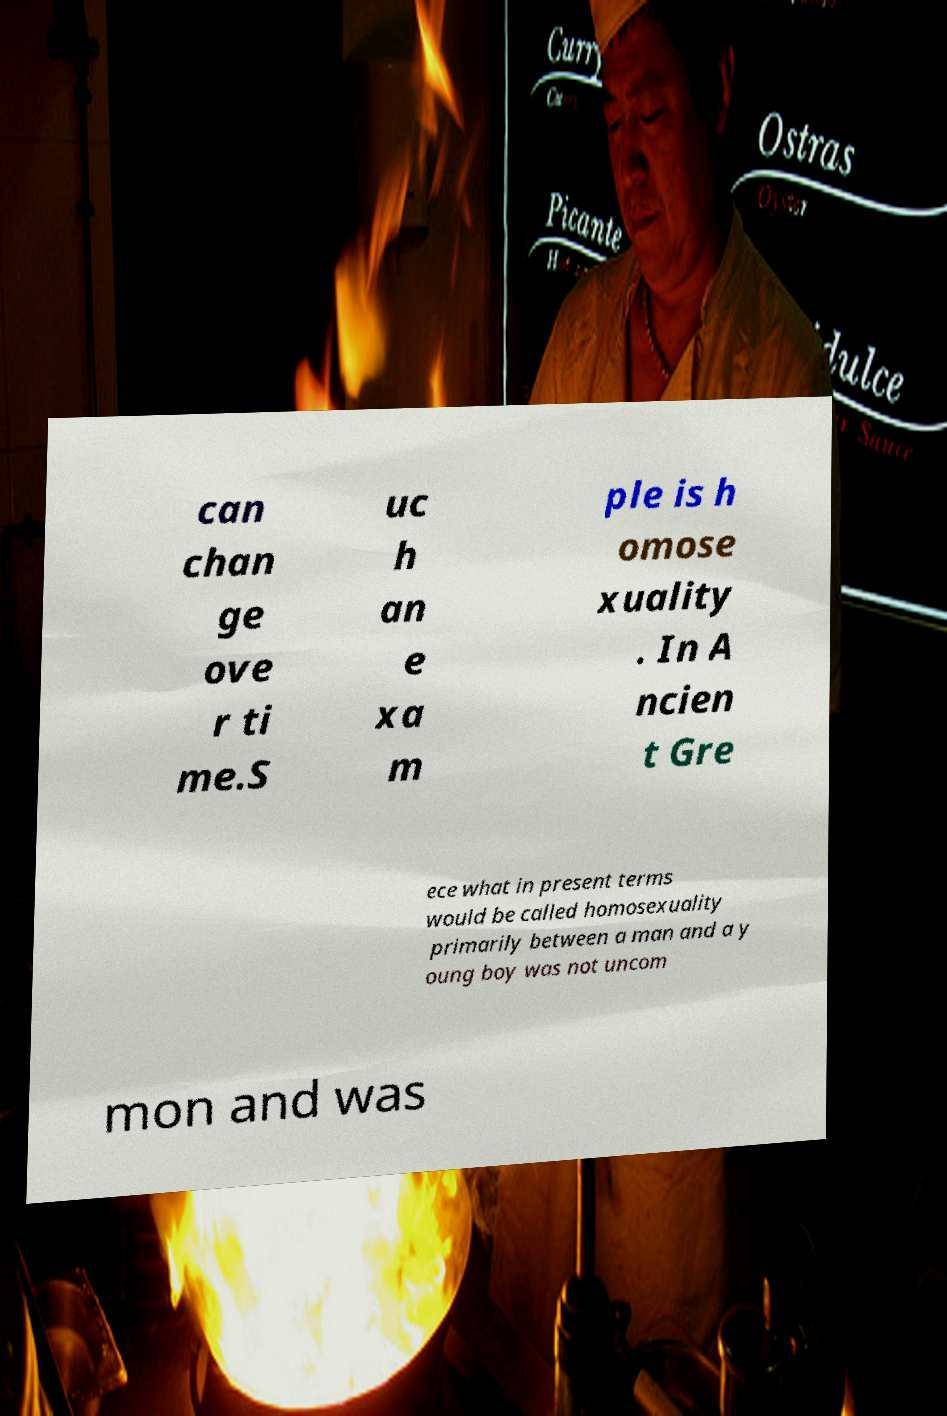Can you read and provide the text displayed in the image?This photo seems to have some interesting text. Can you extract and type it out for me? can chan ge ove r ti me.S uc h an e xa m ple is h omose xuality . In A ncien t Gre ece what in present terms would be called homosexuality primarily between a man and a y oung boy was not uncom mon and was 